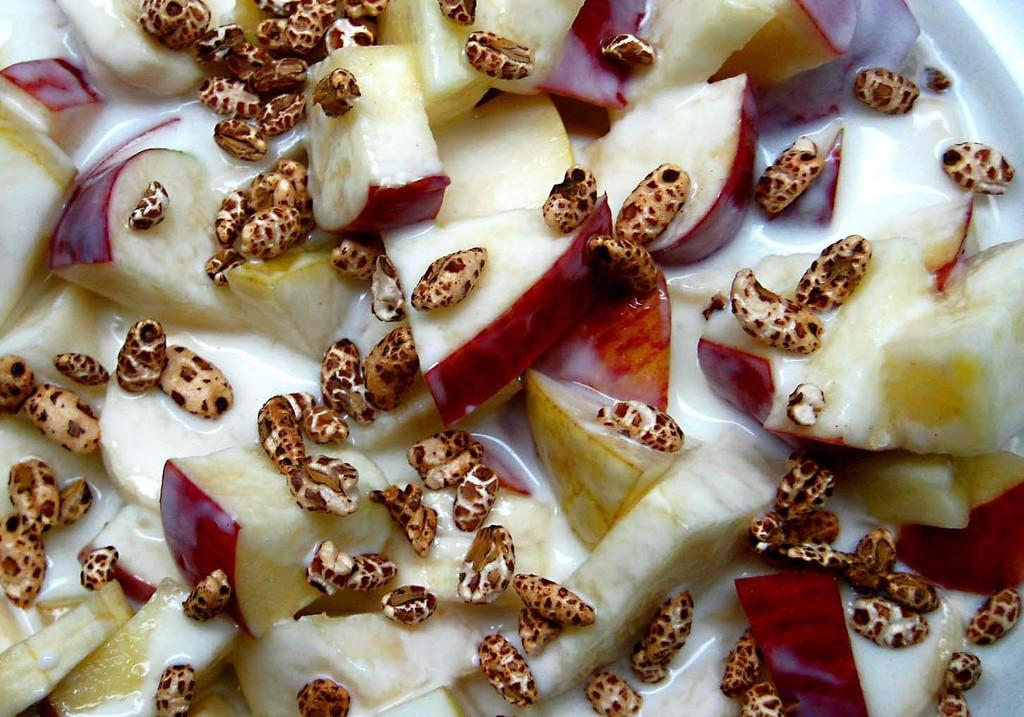What type of food is visible in the image? There are slices of apples in the image. What other type of food can be seen in the image? There is soup in the image. What type of tool does the carpenter use to measure the soup in the image? There is no carpenter or tool present in the image. What type of government official is present in the image? There is no government official, such as a minister, present in the image. 